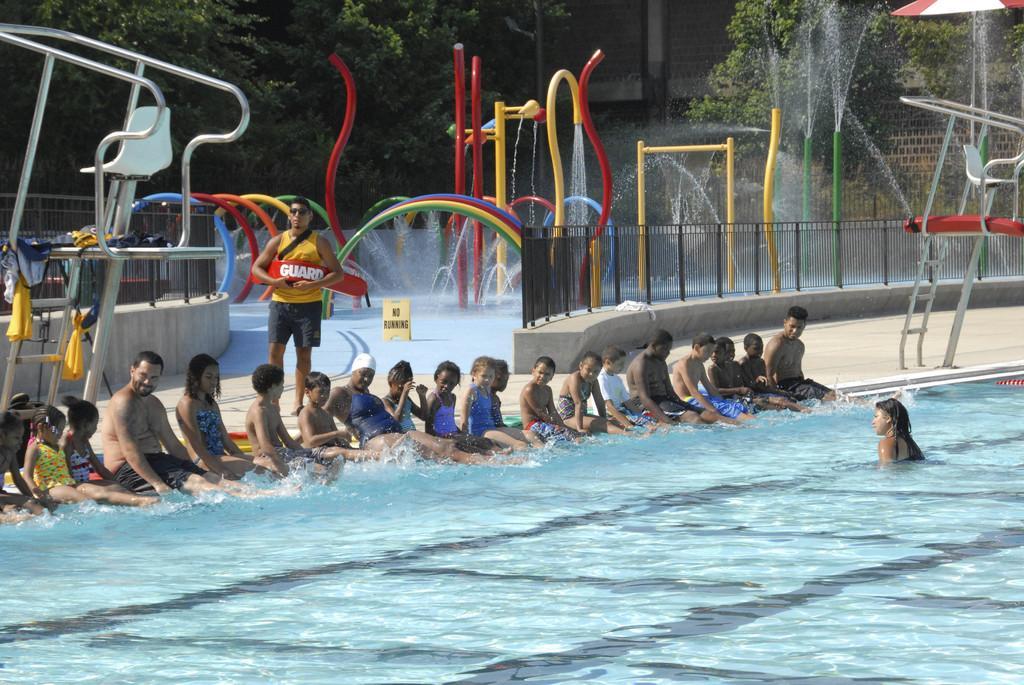Could you give a brief overview of what you see in this image? In the image there are many kids few men and women sitting side of swimming pool, this seems to be in a water park, behind them there is a person standing, in the back there is water fountain and sprinklers with a fence in front of it and over the background there are trees. 